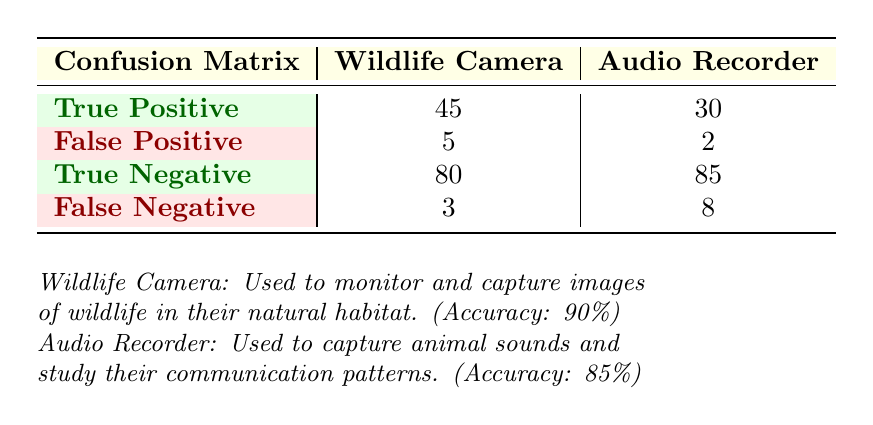What is the True Positive rate for the Wildlife Camera? To find the True Positive rate, we need to divide the number of True Positives for the Wildlife Camera (45) by the total number of instances that should have been correctly identified as positive. This total is the sum of True Positives (45) and False Negatives (3), which equals 48. Therefore, the True Positive rate is 45/48 = 0.9375 or 93.75%.
Answer: 93.75% How many False Positives were recorded for the Audio Recorder? The table shows that the False Positives for the Audio Recorder is directly listed as 2.
Answer: 2 What is the total number of True Negatives for both pieces of equipment? To find the total number of True Negatives, we simply add the True Negatives for both the Wildlife Camera (80) and Audio Recorder (85). Thus, the total is 80 + 85 = 165.
Answer: 165 Is the accuracy for the Wildlife Camera higher than that of the Audio Recorder? The accuracy for the Wildlife Camera is listed as 90%, while for the Audio Recorder it is 85%. Since 90% is greater than 85%, we can confirm that yes, the Wildlife Camera has a higher accuracy.
Answer: Yes What is the combined number of True Positive and True Negative instances for the Wildlife Camera? To find the combined number, we add the True Positives (45) to the True Negatives (80). Hence, the combined number is 45 + 80 = 125.
Answer: 125 How many total instances were classified incorrectly by the Audio Recorder? To find the total incorrectly classified instances, we sum the False Positives (2) and False Negatives (8) for the Audio Recorder. Therefore, the total is 2 + 8 = 10.
Answer: 10 What is the total number of instances evaluated for the Wildlife Camera? The total number of instances can be calculated by summing True Positives (45), False Positives (5), True Negatives (80), and False Negatives (3). Thus, the total is 45 + 5 + 80 + 3 = 133.
Answer: 133 What percentage of instances were classified as False Negatives for the Audio Recorder? To calculate the percentage of False Negatives, we divide the number of False Negatives (8) by the total number of instances for the Audio Recorder, which is 30 (True Positives) + 2 (False Positives) + 85 (True Negatives) + 8 (False Negatives) = 125. So, the percentage is (8/125) * 100 = 6.4%.
Answer: 6.4% What is the overall count of True Positives for both equipment types? To find the overall count of True Positives, we add the True Positives for the Wildlife Camera (45) and for the Audio Recorder (30). Therefore, the total count is 45 + 30 = 75.
Answer: 75 